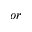<formula> <loc_0><loc_0><loc_500><loc_500>o r</formula> 